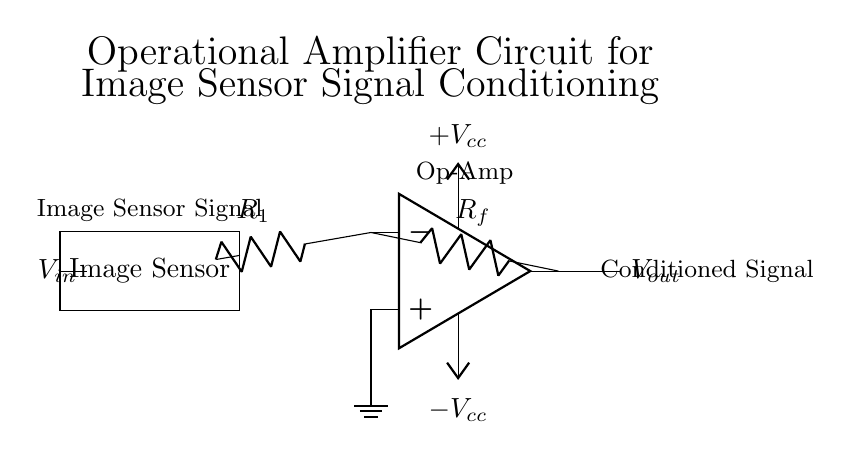What component receives the signal input? The Image Sensor receives the signal input as indicated by the connection labeled V_in leading directly to it.
Answer: Image Sensor What is the purpose of the resistor labeled R_f? The resistor R_f functions as the feedback resistor, which determines the gain of the operational amplifier, thereby influencing how the output signal V_out relates to the input signal V_in.
Answer: Gain adjustment What are the power supply voltages shown in the circuit? The circuit shows two power supply voltages, labeled as plus V_cc and minus V_cc, indicating the operational amplifier has dual supply voltages to operate.
Answer: Plus V_cc and minus V_cc How many terminals does the operational amplifier have? The operational amplifier in the diagram has three terminals: the inverting input, the non-inverting input, and the output.
Answer: Three What is the signal conditioning output labeled as? The conditioned signal output is labeled V_out, which denotes the processed output signal from the operational amplifier after conditioning the input from the image sensor.
Answer: V_out What is the function of the resistor R_1 in this circuit? The resistor R_1 acts as an input resistor providing a specific resistance value to the inverting input of the operational amplifier, which helps set the gain along with R_f.
Answer: Input resistor 